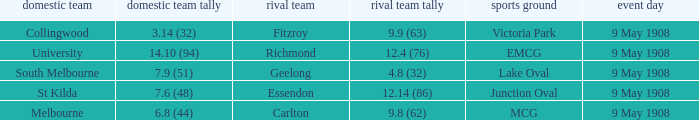Name the home team for carlton away team Melbourne. 